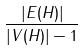<formula> <loc_0><loc_0><loc_500><loc_500>\frac { | E ( H ) | } { | V ( H ) | - 1 }</formula> 